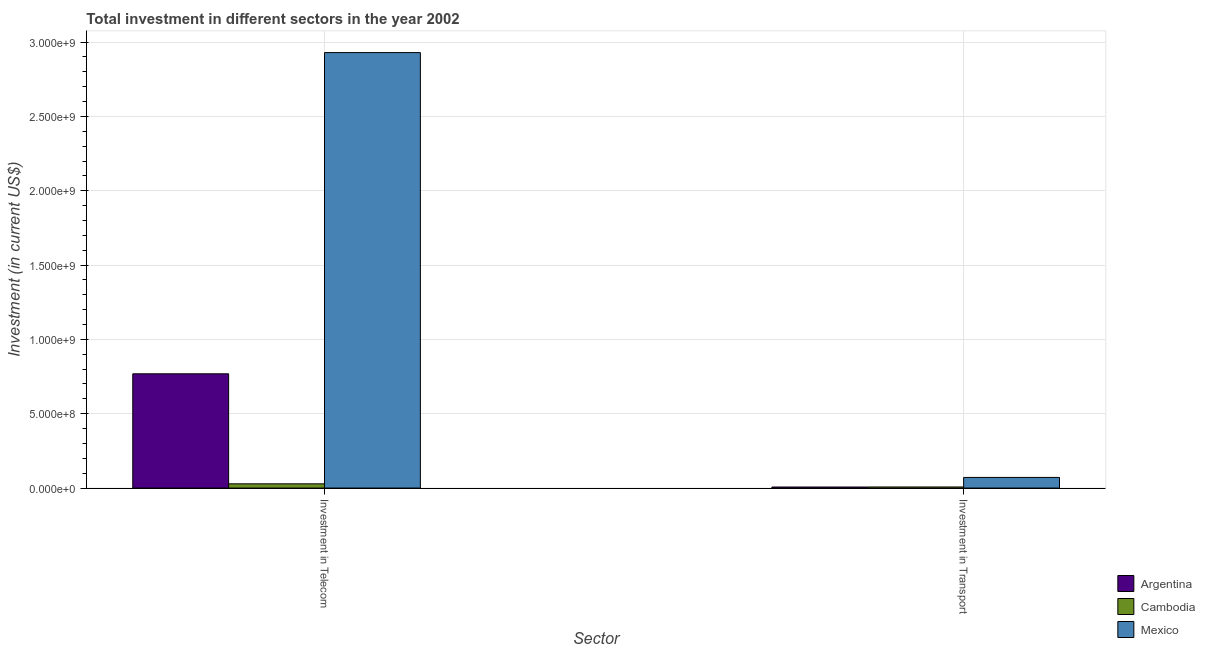How many groups of bars are there?
Keep it short and to the point. 2. Are the number of bars per tick equal to the number of legend labels?
Provide a succinct answer. Yes. Are the number of bars on each tick of the X-axis equal?
Provide a short and direct response. Yes. How many bars are there on the 2nd tick from the right?
Your answer should be compact. 3. What is the label of the 2nd group of bars from the left?
Ensure brevity in your answer.  Investment in Transport. What is the investment in telecom in Mexico?
Your response must be concise. 2.93e+09. Across all countries, what is the maximum investment in telecom?
Provide a succinct answer. 2.93e+09. Across all countries, what is the minimum investment in telecom?
Make the answer very short. 2.84e+07. In which country was the investment in telecom maximum?
Make the answer very short. Mexico. In which country was the investment in telecom minimum?
Your response must be concise. Cambodia. What is the total investment in telecom in the graph?
Give a very brief answer. 3.73e+09. What is the difference between the investment in telecom in Argentina and that in Cambodia?
Make the answer very short. 7.40e+08. What is the difference between the investment in transport in Cambodia and the investment in telecom in Argentina?
Ensure brevity in your answer.  -7.61e+08. What is the average investment in transport per country?
Provide a succinct answer. 2.85e+07. What is the difference between the investment in transport and investment in telecom in Mexico?
Your response must be concise. -2.86e+09. In how many countries, is the investment in telecom greater than 1500000000 US$?
Ensure brevity in your answer.  1. What is the ratio of the investment in transport in Cambodia to that in Argentina?
Offer a terse response. 1.04. Is the investment in telecom in Mexico less than that in Argentina?
Ensure brevity in your answer.  No. In how many countries, is the investment in transport greater than the average investment in transport taken over all countries?
Give a very brief answer. 1. How many bars are there?
Offer a terse response. 6. Are all the bars in the graph horizontal?
Your response must be concise. No. Does the graph contain any zero values?
Make the answer very short. No. Does the graph contain grids?
Keep it short and to the point. Yes. Where does the legend appear in the graph?
Make the answer very short. Bottom right. What is the title of the graph?
Your answer should be compact. Total investment in different sectors in the year 2002. What is the label or title of the X-axis?
Ensure brevity in your answer.  Sector. What is the label or title of the Y-axis?
Give a very brief answer. Investment (in current US$). What is the Investment (in current US$) of Argentina in Investment in Telecom?
Ensure brevity in your answer.  7.69e+08. What is the Investment (in current US$) of Cambodia in Investment in Telecom?
Your answer should be very brief. 2.84e+07. What is the Investment (in current US$) in Mexico in Investment in Telecom?
Your answer should be very brief. 2.93e+09. What is the Investment (in current US$) in Argentina in Investment in Transport?
Your answer should be compact. 6.90e+06. What is the Investment (in current US$) in Cambodia in Investment in Transport?
Keep it short and to the point. 7.20e+06. What is the Investment (in current US$) of Mexico in Investment in Transport?
Your response must be concise. 7.14e+07. Across all Sector, what is the maximum Investment (in current US$) of Argentina?
Offer a very short reply. 7.69e+08. Across all Sector, what is the maximum Investment (in current US$) of Cambodia?
Your response must be concise. 2.84e+07. Across all Sector, what is the maximum Investment (in current US$) of Mexico?
Offer a very short reply. 2.93e+09. Across all Sector, what is the minimum Investment (in current US$) of Argentina?
Your answer should be very brief. 6.90e+06. Across all Sector, what is the minimum Investment (in current US$) of Cambodia?
Your response must be concise. 7.20e+06. Across all Sector, what is the minimum Investment (in current US$) of Mexico?
Offer a terse response. 7.14e+07. What is the total Investment (in current US$) in Argentina in the graph?
Your answer should be compact. 7.76e+08. What is the total Investment (in current US$) in Cambodia in the graph?
Give a very brief answer. 3.56e+07. What is the total Investment (in current US$) in Mexico in the graph?
Keep it short and to the point. 3.00e+09. What is the difference between the Investment (in current US$) in Argentina in Investment in Telecom and that in Investment in Transport?
Offer a very short reply. 7.62e+08. What is the difference between the Investment (in current US$) of Cambodia in Investment in Telecom and that in Investment in Transport?
Offer a terse response. 2.12e+07. What is the difference between the Investment (in current US$) of Mexico in Investment in Telecom and that in Investment in Transport?
Provide a succinct answer. 2.86e+09. What is the difference between the Investment (in current US$) of Argentina in Investment in Telecom and the Investment (in current US$) of Cambodia in Investment in Transport?
Your answer should be very brief. 7.61e+08. What is the difference between the Investment (in current US$) of Argentina in Investment in Telecom and the Investment (in current US$) of Mexico in Investment in Transport?
Offer a very short reply. 6.97e+08. What is the difference between the Investment (in current US$) in Cambodia in Investment in Telecom and the Investment (in current US$) in Mexico in Investment in Transport?
Provide a succinct answer. -4.30e+07. What is the average Investment (in current US$) of Argentina per Sector?
Your answer should be very brief. 3.88e+08. What is the average Investment (in current US$) in Cambodia per Sector?
Make the answer very short. 1.78e+07. What is the average Investment (in current US$) of Mexico per Sector?
Make the answer very short. 1.50e+09. What is the difference between the Investment (in current US$) in Argentina and Investment (in current US$) in Cambodia in Investment in Telecom?
Ensure brevity in your answer.  7.40e+08. What is the difference between the Investment (in current US$) in Argentina and Investment (in current US$) in Mexico in Investment in Telecom?
Ensure brevity in your answer.  -2.16e+09. What is the difference between the Investment (in current US$) of Cambodia and Investment (in current US$) of Mexico in Investment in Telecom?
Offer a very short reply. -2.90e+09. What is the difference between the Investment (in current US$) in Argentina and Investment (in current US$) in Cambodia in Investment in Transport?
Give a very brief answer. -3.00e+05. What is the difference between the Investment (in current US$) in Argentina and Investment (in current US$) in Mexico in Investment in Transport?
Make the answer very short. -6.45e+07. What is the difference between the Investment (in current US$) of Cambodia and Investment (in current US$) of Mexico in Investment in Transport?
Keep it short and to the point. -6.42e+07. What is the ratio of the Investment (in current US$) of Argentina in Investment in Telecom to that in Investment in Transport?
Offer a very short reply. 111.39. What is the ratio of the Investment (in current US$) in Cambodia in Investment in Telecom to that in Investment in Transport?
Make the answer very short. 3.94. What is the ratio of the Investment (in current US$) of Mexico in Investment in Telecom to that in Investment in Transport?
Make the answer very short. 41.03. What is the difference between the highest and the second highest Investment (in current US$) of Argentina?
Ensure brevity in your answer.  7.62e+08. What is the difference between the highest and the second highest Investment (in current US$) in Cambodia?
Provide a short and direct response. 2.12e+07. What is the difference between the highest and the second highest Investment (in current US$) of Mexico?
Make the answer very short. 2.86e+09. What is the difference between the highest and the lowest Investment (in current US$) in Argentina?
Keep it short and to the point. 7.62e+08. What is the difference between the highest and the lowest Investment (in current US$) of Cambodia?
Your answer should be very brief. 2.12e+07. What is the difference between the highest and the lowest Investment (in current US$) in Mexico?
Offer a terse response. 2.86e+09. 